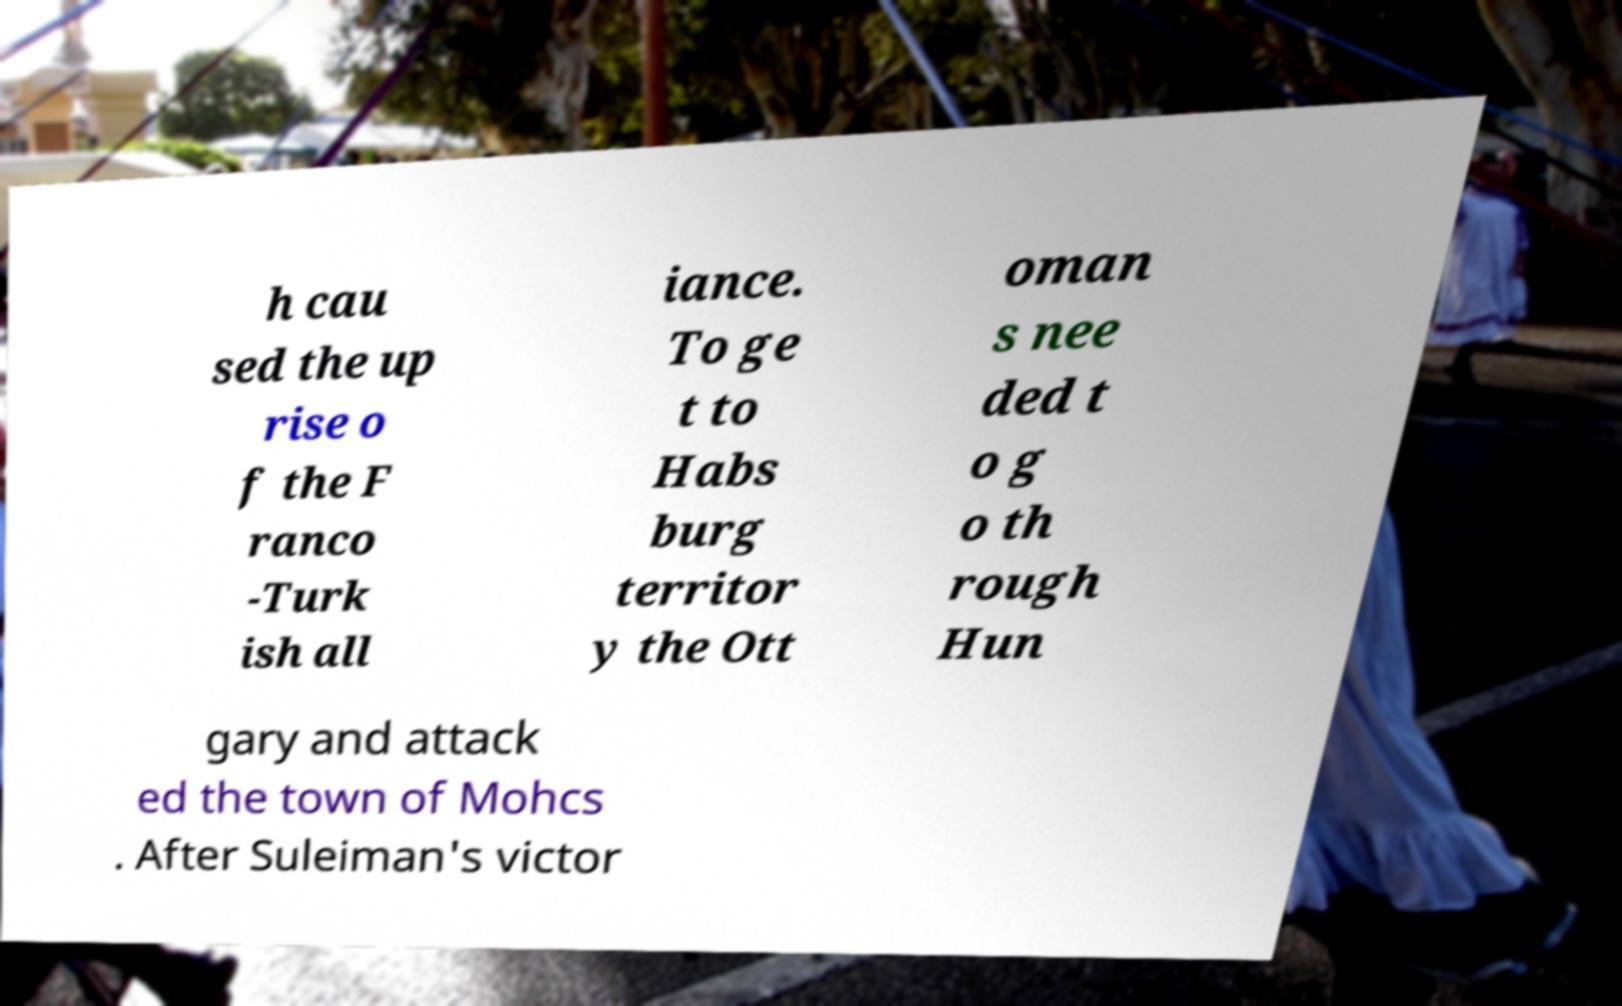Can you read and provide the text displayed in the image?This photo seems to have some interesting text. Can you extract and type it out for me? h cau sed the up rise o f the F ranco -Turk ish all iance. To ge t to Habs burg territor y the Ott oman s nee ded t o g o th rough Hun gary and attack ed the town of Mohcs . After Suleiman's victor 